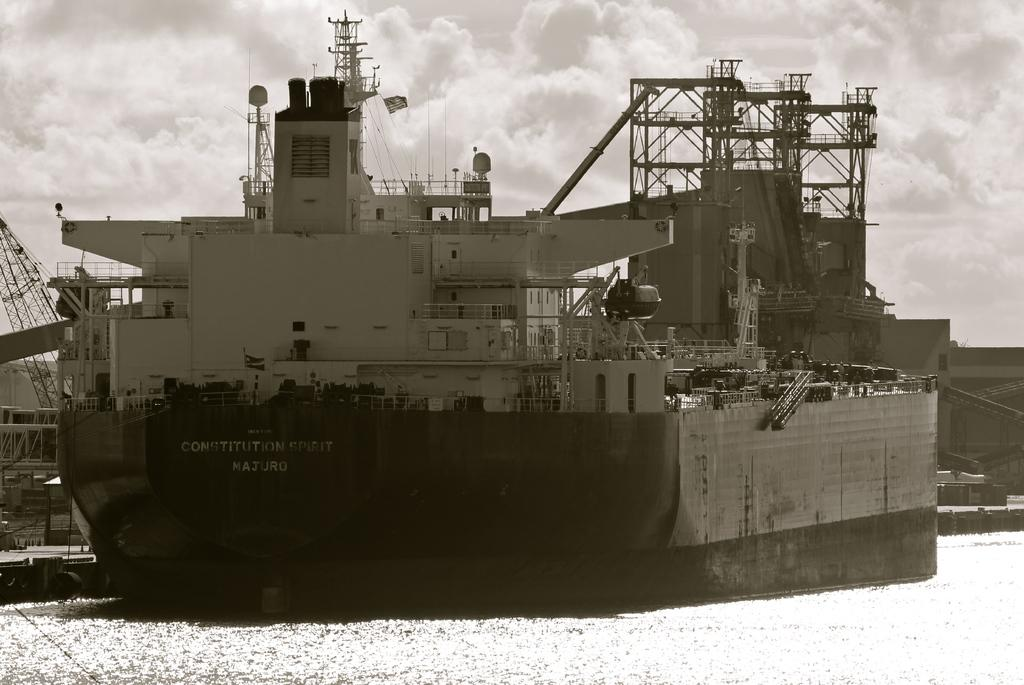What type of ship is in the image? There is a troop ship in the image. Where is the troop ship located? The troop ship is on the water surface. How big is the troop ship? The troop ship is described as very huge. How many beds are on the troop ship in the image? There is no information about beds on the troop ship in the image. 